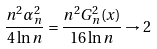Convert formula to latex. <formula><loc_0><loc_0><loc_500><loc_500>\frac { n ^ { 2 } \alpha _ { n } ^ { 2 } } { 4 \ln n } = \frac { n ^ { 2 } G _ { n } ^ { 2 } ( x ) } { 1 6 \ln n } \to 2</formula> 